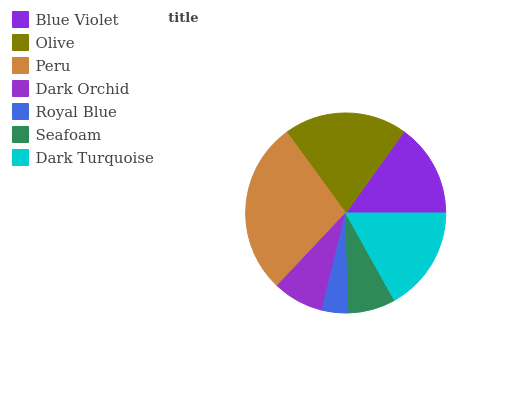Is Royal Blue the minimum?
Answer yes or no. Yes. Is Peru the maximum?
Answer yes or no. Yes. Is Olive the minimum?
Answer yes or no. No. Is Olive the maximum?
Answer yes or no. No. Is Olive greater than Blue Violet?
Answer yes or no. Yes. Is Blue Violet less than Olive?
Answer yes or no. Yes. Is Blue Violet greater than Olive?
Answer yes or no. No. Is Olive less than Blue Violet?
Answer yes or no. No. Is Blue Violet the high median?
Answer yes or no. Yes. Is Blue Violet the low median?
Answer yes or no. Yes. Is Royal Blue the high median?
Answer yes or no. No. Is Peru the low median?
Answer yes or no. No. 